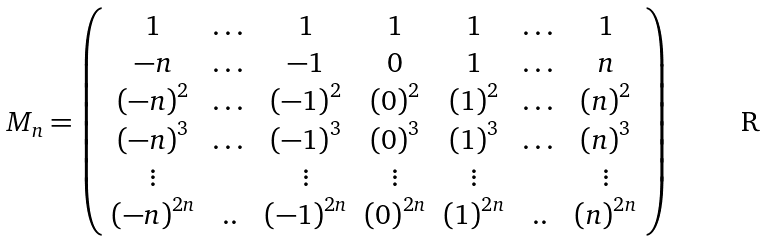<formula> <loc_0><loc_0><loc_500><loc_500>M _ { n } = \left ( \begin{array} { c c c c c c c } 1 & \dots & 1 & 1 & 1 & \dots & 1 \\ - n & \dots & - 1 & 0 & 1 & \dots & n \\ \left ( - n \right ) ^ { 2 } & \dots & \left ( - 1 \right ) ^ { 2 } & \left ( 0 \right ) ^ { 2 } & \left ( 1 \right ) ^ { 2 } & \dots & \left ( n \right ) ^ { 2 } \\ \left ( - n \right ) ^ { 3 } & \dots & \left ( - 1 \right ) ^ { 3 } & \left ( 0 \right ) ^ { 3 } & \left ( 1 \right ) ^ { 3 } & \dots & \left ( n \right ) ^ { 3 } \\ \vdots & & \vdots & \vdots & \vdots & & \vdots \\ \left ( - n \right ) ^ { 2 n } & . . & \left ( - 1 \right ) ^ { 2 n } & \left ( 0 \right ) ^ { 2 n } & \left ( 1 \right ) ^ { 2 n } & . . & \left ( n \right ) ^ { 2 n } \end{array} \right )</formula> 